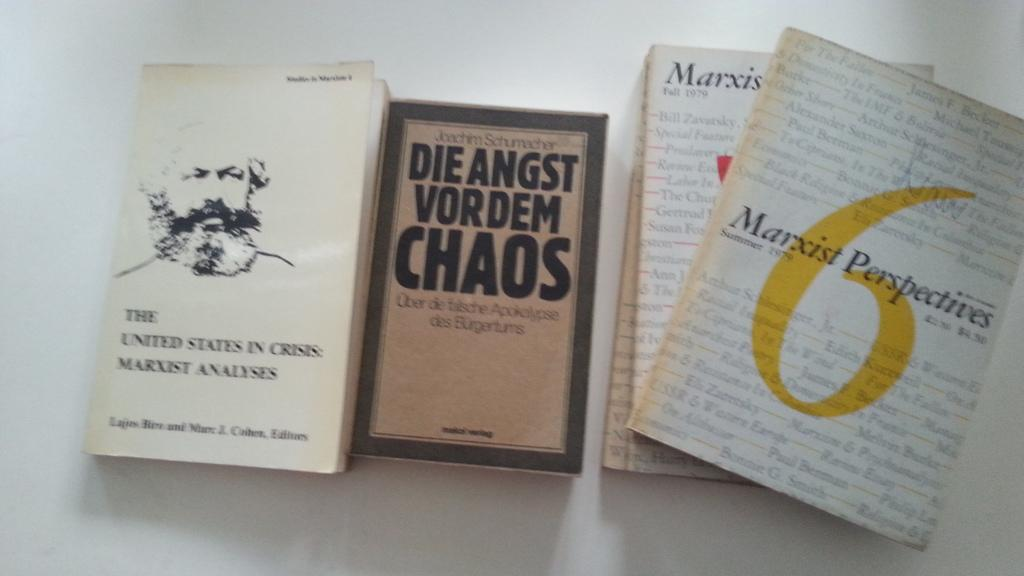<image>
Describe the image concisely. A few books which titles include Marxist Perspectives. 